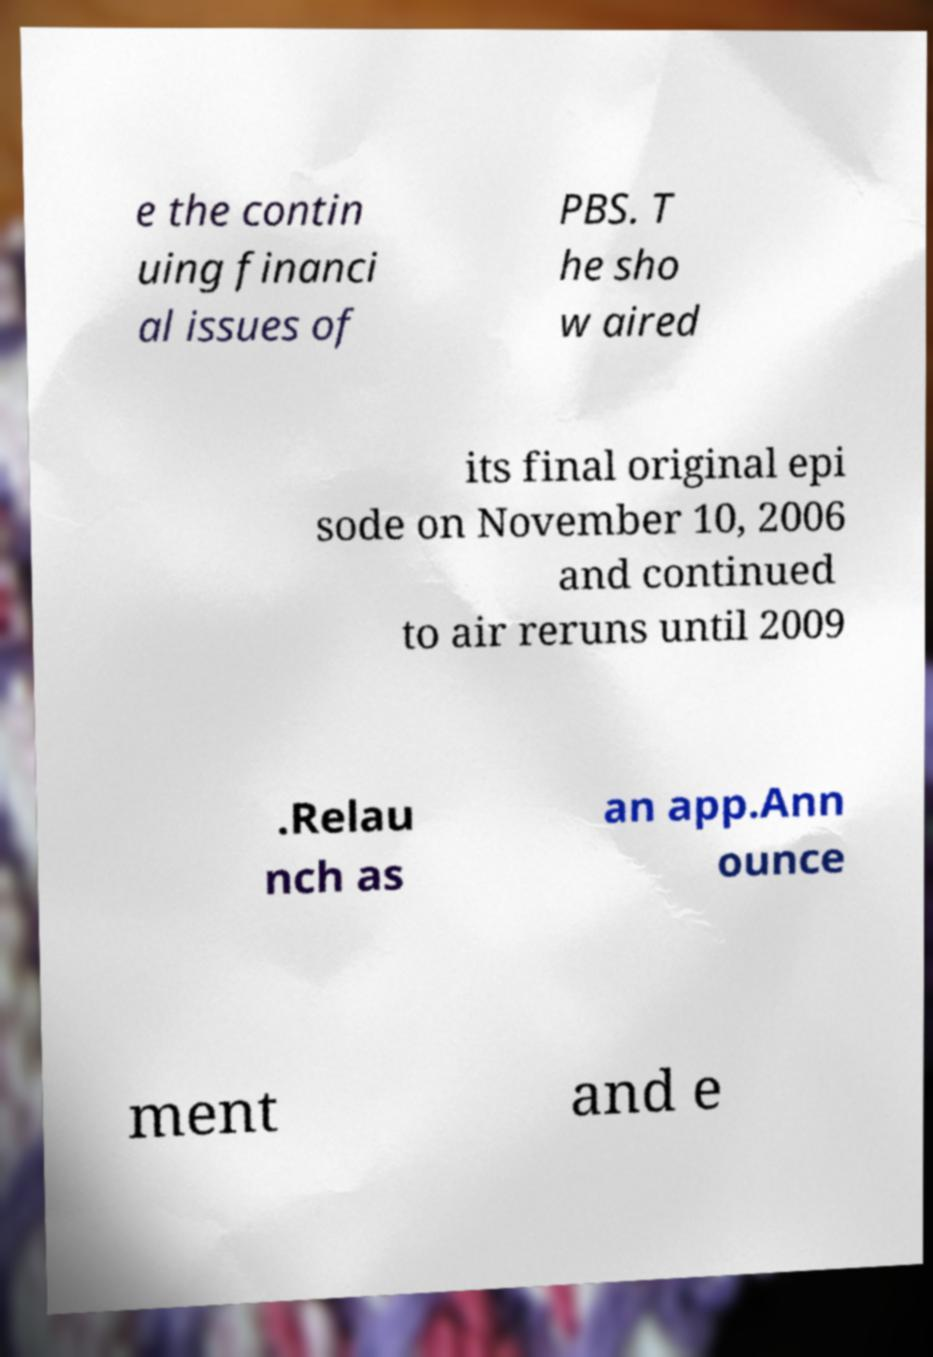For documentation purposes, I need the text within this image transcribed. Could you provide that? e the contin uing financi al issues of PBS. T he sho w aired its final original epi sode on November 10, 2006 and continued to air reruns until 2009 .Relau nch as an app.Ann ounce ment and e 